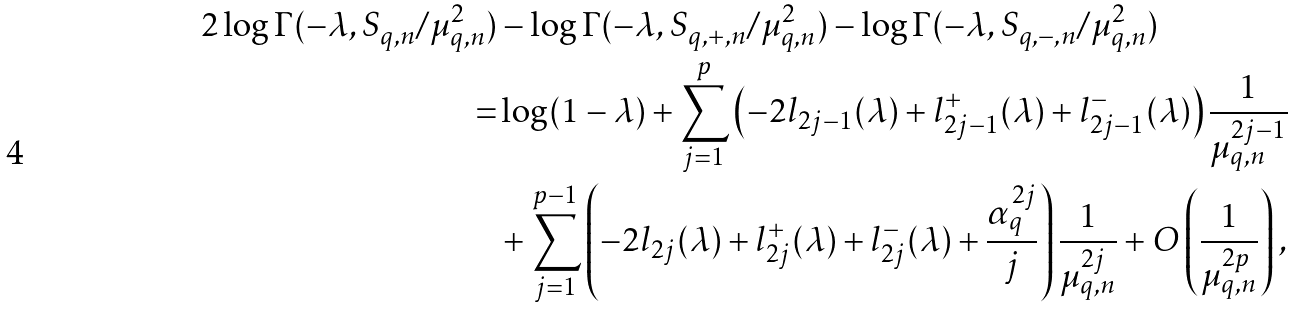<formula> <loc_0><loc_0><loc_500><loc_500>2 \log \Gamma ( - \lambda , S _ { q , n } / \mu _ { q , n } ^ { 2 } ) & - \log \Gamma ( - \lambda , S _ { q , + , n } / \mu _ { q , n } ^ { 2 } ) - \log \Gamma ( - \lambda , S _ { q , - , n } / \mu _ { q , n } ^ { 2 } ) \\ = & \log ( 1 - \lambda ) + \sum _ { j = 1 } ^ { p } \left ( - 2 l _ { 2 j - 1 } ( \lambda ) + l ^ { + } _ { 2 j - 1 } ( \lambda ) + l ^ { - } _ { 2 j - 1 } ( \lambda ) \right ) \frac { 1 } { \mu _ { q , n } ^ { 2 j - 1 } } \\ & + \sum _ { j = 1 } ^ { p - 1 } \left ( - 2 l _ { 2 j } ( \lambda ) + l ^ { + } _ { 2 j } ( \lambda ) + l ^ { - } _ { 2 j } ( \lambda ) + \frac { \alpha _ { q } ^ { 2 j } } { j } \right ) \frac { 1 } { \mu _ { q , n } ^ { 2 j } } + O \left ( \frac { 1 } { \mu _ { q , n } ^ { 2 p } } \right ) ,</formula> 